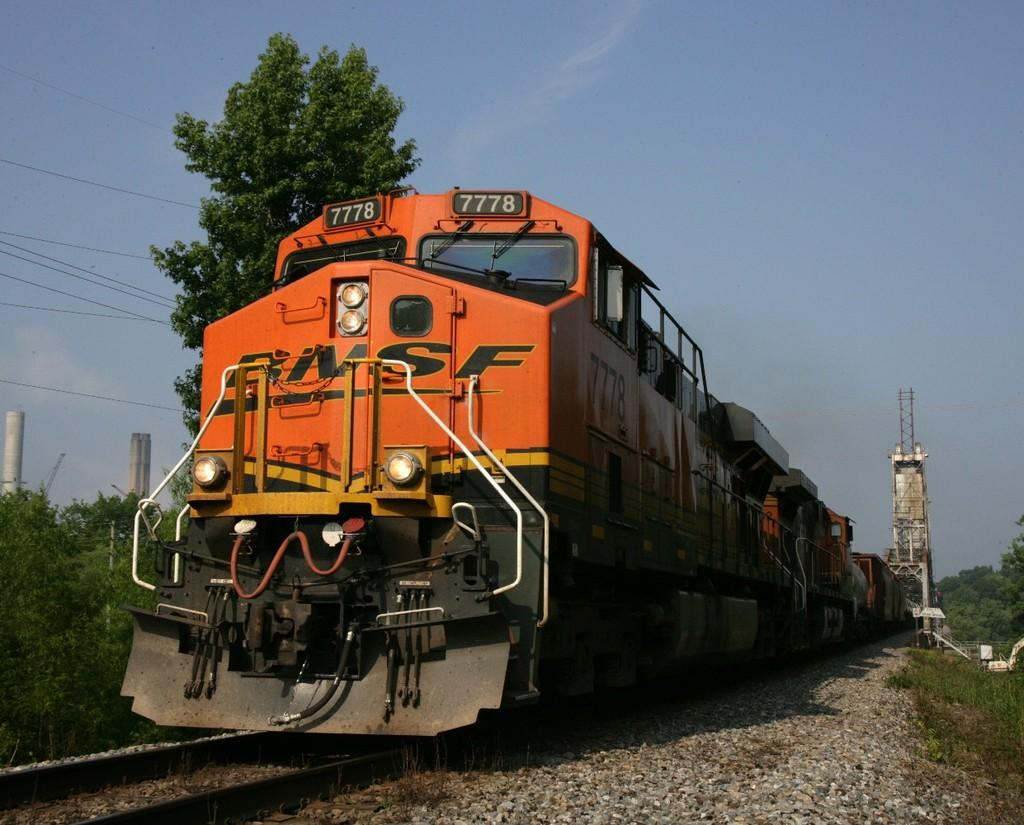What is the main subject of the image? The main subject of the image is a train. What can be seen alongside the train in the image? There is a railway track in the image. What other structures or objects are visible in the image? There is a building, a tree, and grass in the image. What type of vegetation is present in the image? There are plants in the image. What is visible at the top of the image? The sky is visible at the top of the image. What type of cart is being pulled by the animal in the image? There is no cart or animal present in the image; it features a train, railway track, building, tree, grass, plants, and the sky. 